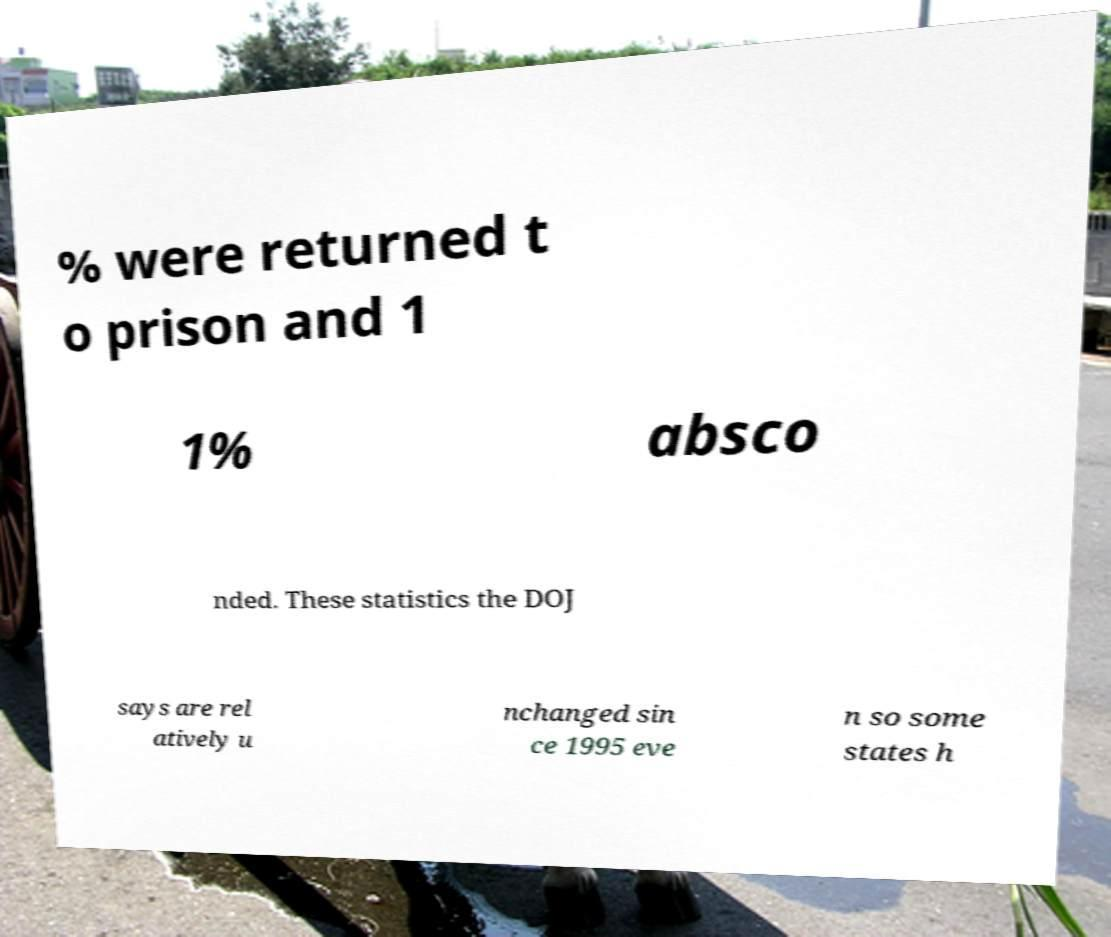Can you accurately transcribe the text from the provided image for me? % were returned t o prison and 1 1% absco nded. These statistics the DOJ says are rel atively u nchanged sin ce 1995 eve n so some states h 